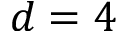Convert formula to latex. <formula><loc_0><loc_0><loc_500><loc_500>d = 4</formula> 